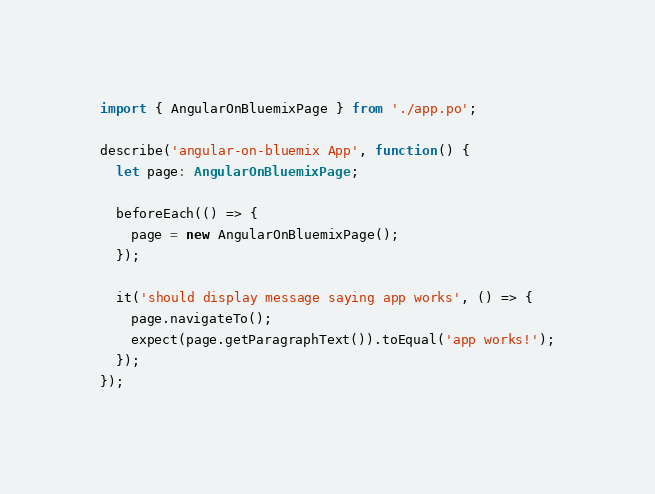<code> <loc_0><loc_0><loc_500><loc_500><_TypeScript_>import { AngularOnBluemixPage } from './app.po';

describe('angular-on-bluemix App', function() {
  let page: AngularOnBluemixPage;

  beforeEach(() => {
    page = new AngularOnBluemixPage();
  });

  it('should display message saying app works', () => {
    page.navigateTo();
    expect(page.getParagraphText()).toEqual('app works!');
  });
});
</code> 